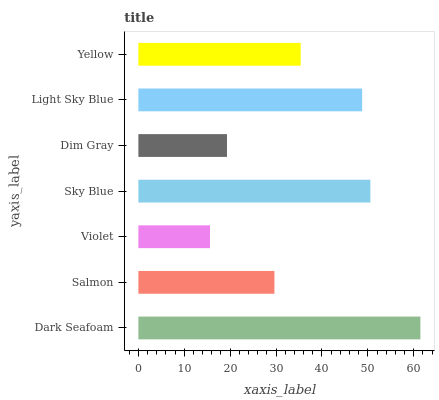Is Violet the minimum?
Answer yes or no. Yes. Is Dark Seafoam the maximum?
Answer yes or no. Yes. Is Salmon the minimum?
Answer yes or no. No. Is Salmon the maximum?
Answer yes or no. No. Is Dark Seafoam greater than Salmon?
Answer yes or no. Yes. Is Salmon less than Dark Seafoam?
Answer yes or no. Yes. Is Salmon greater than Dark Seafoam?
Answer yes or no. No. Is Dark Seafoam less than Salmon?
Answer yes or no. No. Is Yellow the high median?
Answer yes or no. Yes. Is Yellow the low median?
Answer yes or no. Yes. Is Dark Seafoam the high median?
Answer yes or no. No. Is Sky Blue the low median?
Answer yes or no. No. 